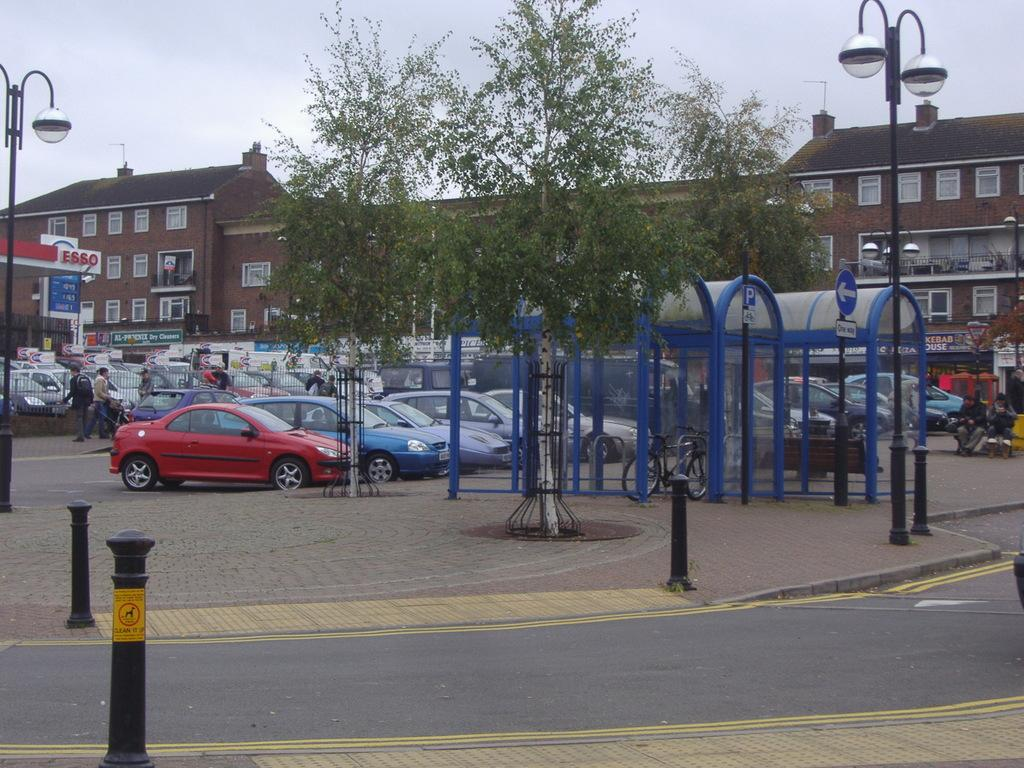What type of vehicles can be seen on the road in the image? There are cars on the road in the image. What are the people in the image doing? The people in the image are standing. What type of footwear is visible in the image? There are boots visible in the image. What type of plant is present in the image? There is a tree in the image. What type of structures are present in the image? There are street light poles and buildings in the image. How many brothers are sitting on the tree in the image? There are no brothers present in the image, and the tree does not have any people sitting on it. What type of sugar is being used to sweeten the boots in the image? There is no sugar present in the image, and the boots are not being sweetened. 